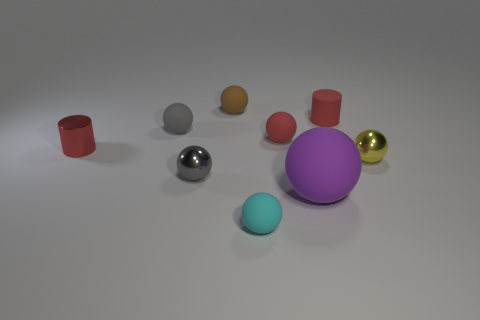What colors are the spheres in the image? The spheres come in various colors including gray, purple, yellow, and a lighter shade of turquoise. 